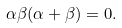<formula> <loc_0><loc_0><loc_500><loc_500>\alpha \beta ( \alpha + \beta ) = 0 .</formula> 